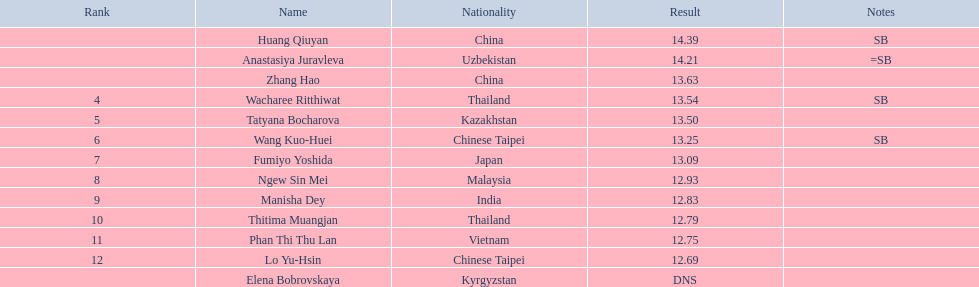What nationality was the woman who won first place? China. 